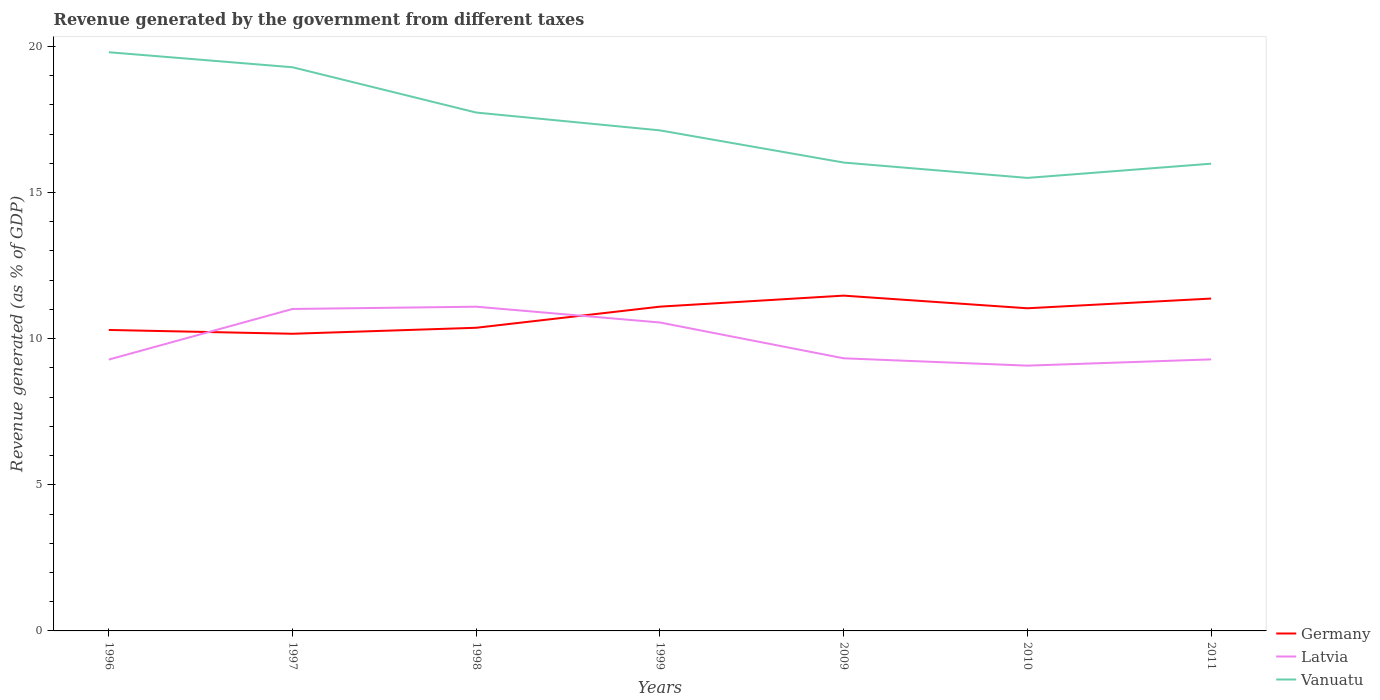Does the line corresponding to Germany intersect with the line corresponding to Latvia?
Your answer should be compact. Yes. Across all years, what is the maximum revenue generated by the government in Vanuatu?
Your response must be concise. 15.5. What is the total revenue generated by the government in Vanuatu in the graph?
Give a very brief answer. 2.24. What is the difference between the highest and the second highest revenue generated by the government in Germany?
Offer a terse response. 1.3. What is the difference between the highest and the lowest revenue generated by the government in Vanuatu?
Give a very brief answer. 3. Is the revenue generated by the government in Latvia strictly greater than the revenue generated by the government in Germany over the years?
Offer a terse response. No. How many lines are there?
Your answer should be very brief. 3. How many years are there in the graph?
Give a very brief answer. 7. Are the values on the major ticks of Y-axis written in scientific E-notation?
Give a very brief answer. No. Does the graph contain any zero values?
Offer a terse response. No. Where does the legend appear in the graph?
Provide a succinct answer. Bottom right. What is the title of the graph?
Keep it short and to the point. Revenue generated by the government from different taxes. What is the label or title of the Y-axis?
Give a very brief answer. Revenue generated (as % of GDP). What is the Revenue generated (as % of GDP) in Germany in 1996?
Offer a very short reply. 10.3. What is the Revenue generated (as % of GDP) in Latvia in 1996?
Your answer should be compact. 9.28. What is the Revenue generated (as % of GDP) in Vanuatu in 1996?
Provide a succinct answer. 19.8. What is the Revenue generated (as % of GDP) of Germany in 1997?
Your answer should be compact. 10.17. What is the Revenue generated (as % of GDP) of Latvia in 1997?
Ensure brevity in your answer.  11.02. What is the Revenue generated (as % of GDP) of Vanuatu in 1997?
Offer a terse response. 19.28. What is the Revenue generated (as % of GDP) of Germany in 1998?
Give a very brief answer. 10.37. What is the Revenue generated (as % of GDP) in Latvia in 1998?
Offer a very short reply. 11.09. What is the Revenue generated (as % of GDP) in Vanuatu in 1998?
Your answer should be compact. 17.73. What is the Revenue generated (as % of GDP) of Germany in 1999?
Your answer should be compact. 11.09. What is the Revenue generated (as % of GDP) of Latvia in 1999?
Keep it short and to the point. 10.55. What is the Revenue generated (as % of GDP) in Vanuatu in 1999?
Ensure brevity in your answer.  17.13. What is the Revenue generated (as % of GDP) in Germany in 2009?
Your answer should be compact. 11.47. What is the Revenue generated (as % of GDP) in Latvia in 2009?
Your answer should be compact. 9.33. What is the Revenue generated (as % of GDP) in Vanuatu in 2009?
Provide a short and direct response. 16.02. What is the Revenue generated (as % of GDP) of Germany in 2010?
Ensure brevity in your answer.  11.04. What is the Revenue generated (as % of GDP) in Latvia in 2010?
Offer a terse response. 9.08. What is the Revenue generated (as % of GDP) of Vanuatu in 2010?
Make the answer very short. 15.5. What is the Revenue generated (as % of GDP) of Germany in 2011?
Your response must be concise. 11.37. What is the Revenue generated (as % of GDP) of Latvia in 2011?
Offer a very short reply. 9.29. What is the Revenue generated (as % of GDP) in Vanuatu in 2011?
Offer a terse response. 15.99. Across all years, what is the maximum Revenue generated (as % of GDP) of Germany?
Offer a terse response. 11.47. Across all years, what is the maximum Revenue generated (as % of GDP) in Latvia?
Your answer should be very brief. 11.09. Across all years, what is the maximum Revenue generated (as % of GDP) in Vanuatu?
Offer a very short reply. 19.8. Across all years, what is the minimum Revenue generated (as % of GDP) in Germany?
Ensure brevity in your answer.  10.17. Across all years, what is the minimum Revenue generated (as % of GDP) of Latvia?
Offer a very short reply. 9.08. Across all years, what is the minimum Revenue generated (as % of GDP) of Vanuatu?
Offer a very short reply. 15.5. What is the total Revenue generated (as % of GDP) of Germany in the graph?
Provide a succinct answer. 75.81. What is the total Revenue generated (as % of GDP) of Latvia in the graph?
Ensure brevity in your answer.  69.64. What is the total Revenue generated (as % of GDP) of Vanuatu in the graph?
Make the answer very short. 121.45. What is the difference between the Revenue generated (as % of GDP) in Germany in 1996 and that in 1997?
Your response must be concise. 0.13. What is the difference between the Revenue generated (as % of GDP) of Latvia in 1996 and that in 1997?
Give a very brief answer. -1.73. What is the difference between the Revenue generated (as % of GDP) in Vanuatu in 1996 and that in 1997?
Your answer should be compact. 0.51. What is the difference between the Revenue generated (as % of GDP) of Germany in 1996 and that in 1998?
Your answer should be very brief. -0.07. What is the difference between the Revenue generated (as % of GDP) in Latvia in 1996 and that in 1998?
Provide a short and direct response. -1.81. What is the difference between the Revenue generated (as % of GDP) in Vanuatu in 1996 and that in 1998?
Provide a short and direct response. 2.06. What is the difference between the Revenue generated (as % of GDP) in Germany in 1996 and that in 1999?
Your answer should be very brief. -0.8. What is the difference between the Revenue generated (as % of GDP) of Latvia in 1996 and that in 1999?
Give a very brief answer. -1.27. What is the difference between the Revenue generated (as % of GDP) of Vanuatu in 1996 and that in 1999?
Provide a succinct answer. 2.67. What is the difference between the Revenue generated (as % of GDP) of Germany in 1996 and that in 2009?
Your answer should be compact. -1.17. What is the difference between the Revenue generated (as % of GDP) in Latvia in 1996 and that in 2009?
Offer a terse response. -0.04. What is the difference between the Revenue generated (as % of GDP) of Vanuatu in 1996 and that in 2009?
Provide a succinct answer. 3.77. What is the difference between the Revenue generated (as % of GDP) of Germany in 1996 and that in 2010?
Keep it short and to the point. -0.74. What is the difference between the Revenue generated (as % of GDP) of Latvia in 1996 and that in 2010?
Keep it short and to the point. 0.21. What is the difference between the Revenue generated (as % of GDP) of Vanuatu in 1996 and that in 2010?
Provide a short and direct response. 4.3. What is the difference between the Revenue generated (as % of GDP) in Germany in 1996 and that in 2011?
Your answer should be compact. -1.07. What is the difference between the Revenue generated (as % of GDP) in Latvia in 1996 and that in 2011?
Keep it short and to the point. -0.01. What is the difference between the Revenue generated (as % of GDP) of Vanuatu in 1996 and that in 2011?
Give a very brief answer. 3.81. What is the difference between the Revenue generated (as % of GDP) of Germany in 1997 and that in 1998?
Offer a terse response. -0.21. What is the difference between the Revenue generated (as % of GDP) of Latvia in 1997 and that in 1998?
Your answer should be very brief. -0.08. What is the difference between the Revenue generated (as % of GDP) of Vanuatu in 1997 and that in 1998?
Your answer should be very brief. 1.55. What is the difference between the Revenue generated (as % of GDP) of Germany in 1997 and that in 1999?
Give a very brief answer. -0.93. What is the difference between the Revenue generated (as % of GDP) in Latvia in 1997 and that in 1999?
Give a very brief answer. 0.46. What is the difference between the Revenue generated (as % of GDP) in Vanuatu in 1997 and that in 1999?
Offer a terse response. 2.16. What is the difference between the Revenue generated (as % of GDP) of Germany in 1997 and that in 2009?
Provide a succinct answer. -1.3. What is the difference between the Revenue generated (as % of GDP) in Latvia in 1997 and that in 2009?
Give a very brief answer. 1.69. What is the difference between the Revenue generated (as % of GDP) in Vanuatu in 1997 and that in 2009?
Keep it short and to the point. 3.26. What is the difference between the Revenue generated (as % of GDP) of Germany in 1997 and that in 2010?
Provide a short and direct response. -0.87. What is the difference between the Revenue generated (as % of GDP) in Latvia in 1997 and that in 2010?
Give a very brief answer. 1.94. What is the difference between the Revenue generated (as % of GDP) in Vanuatu in 1997 and that in 2010?
Provide a short and direct response. 3.79. What is the difference between the Revenue generated (as % of GDP) in Germany in 1997 and that in 2011?
Provide a succinct answer. -1.2. What is the difference between the Revenue generated (as % of GDP) in Latvia in 1997 and that in 2011?
Keep it short and to the point. 1.72. What is the difference between the Revenue generated (as % of GDP) in Vanuatu in 1997 and that in 2011?
Keep it short and to the point. 3.3. What is the difference between the Revenue generated (as % of GDP) of Germany in 1998 and that in 1999?
Give a very brief answer. -0.72. What is the difference between the Revenue generated (as % of GDP) of Latvia in 1998 and that in 1999?
Offer a very short reply. 0.54. What is the difference between the Revenue generated (as % of GDP) of Vanuatu in 1998 and that in 1999?
Your response must be concise. 0.61. What is the difference between the Revenue generated (as % of GDP) in Germany in 1998 and that in 2009?
Make the answer very short. -1.1. What is the difference between the Revenue generated (as % of GDP) of Latvia in 1998 and that in 2009?
Provide a short and direct response. 1.77. What is the difference between the Revenue generated (as % of GDP) of Vanuatu in 1998 and that in 2009?
Offer a terse response. 1.71. What is the difference between the Revenue generated (as % of GDP) in Germany in 1998 and that in 2010?
Keep it short and to the point. -0.67. What is the difference between the Revenue generated (as % of GDP) of Latvia in 1998 and that in 2010?
Provide a succinct answer. 2.02. What is the difference between the Revenue generated (as % of GDP) of Vanuatu in 1998 and that in 2010?
Keep it short and to the point. 2.24. What is the difference between the Revenue generated (as % of GDP) of Germany in 1998 and that in 2011?
Offer a terse response. -1. What is the difference between the Revenue generated (as % of GDP) in Latvia in 1998 and that in 2011?
Your response must be concise. 1.8. What is the difference between the Revenue generated (as % of GDP) in Vanuatu in 1998 and that in 2011?
Give a very brief answer. 1.75. What is the difference between the Revenue generated (as % of GDP) in Germany in 1999 and that in 2009?
Offer a terse response. -0.38. What is the difference between the Revenue generated (as % of GDP) of Latvia in 1999 and that in 2009?
Ensure brevity in your answer.  1.23. What is the difference between the Revenue generated (as % of GDP) in Vanuatu in 1999 and that in 2009?
Your response must be concise. 1.1. What is the difference between the Revenue generated (as % of GDP) of Germany in 1999 and that in 2010?
Provide a short and direct response. 0.06. What is the difference between the Revenue generated (as % of GDP) of Latvia in 1999 and that in 2010?
Ensure brevity in your answer.  1.48. What is the difference between the Revenue generated (as % of GDP) of Vanuatu in 1999 and that in 2010?
Offer a very short reply. 1.63. What is the difference between the Revenue generated (as % of GDP) in Germany in 1999 and that in 2011?
Offer a terse response. -0.28. What is the difference between the Revenue generated (as % of GDP) of Latvia in 1999 and that in 2011?
Ensure brevity in your answer.  1.26. What is the difference between the Revenue generated (as % of GDP) in Vanuatu in 1999 and that in 2011?
Your response must be concise. 1.14. What is the difference between the Revenue generated (as % of GDP) of Germany in 2009 and that in 2010?
Keep it short and to the point. 0.43. What is the difference between the Revenue generated (as % of GDP) in Latvia in 2009 and that in 2010?
Provide a succinct answer. 0.25. What is the difference between the Revenue generated (as % of GDP) of Vanuatu in 2009 and that in 2010?
Your answer should be compact. 0.53. What is the difference between the Revenue generated (as % of GDP) of Germany in 2009 and that in 2011?
Provide a succinct answer. 0.1. What is the difference between the Revenue generated (as % of GDP) of Latvia in 2009 and that in 2011?
Provide a succinct answer. 0.04. What is the difference between the Revenue generated (as % of GDP) in Vanuatu in 2009 and that in 2011?
Your answer should be very brief. 0.04. What is the difference between the Revenue generated (as % of GDP) of Germany in 2010 and that in 2011?
Provide a short and direct response. -0.33. What is the difference between the Revenue generated (as % of GDP) in Latvia in 2010 and that in 2011?
Your answer should be very brief. -0.21. What is the difference between the Revenue generated (as % of GDP) of Vanuatu in 2010 and that in 2011?
Make the answer very short. -0.49. What is the difference between the Revenue generated (as % of GDP) in Germany in 1996 and the Revenue generated (as % of GDP) in Latvia in 1997?
Offer a terse response. -0.72. What is the difference between the Revenue generated (as % of GDP) of Germany in 1996 and the Revenue generated (as % of GDP) of Vanuatu in 1997?
Keep it short and to the point. -8.99. What is the difference between the Revenue generated (as % of GDP) of Latvia in 1996 and the Revenue generated (as % of GDP) of Vanuatu in 1997?
Keep it short and to the point. -10. What is the difference between the Revenue generated (as % of GDP) in Germany in 1996 and the Revenue generated (as % of GDP) in Latvia in 1998?
Provide a short and direct response. -0.8. What is the difference between the Revenue generated (as % of GDP) in Germany in 1996 and the Revenue generated (as % of GDP) in Vanuatu in 1998?
Provide a short and direct response. -7.44. What is the difference between the Revenue generated (as % of GDP) of Latvia in 1996 and the Revenue generated (as % of GDP) of Vanuatu in 1998?
Your answer should be very brief. -8.45. What is the difference between the Revenue generated (as % of GDP) in Germany in 1996 and the Revenue generated (as % of GDP) in Latvia in 1999?
Provide a succinct answer. -0.26. What is the difference between the Revenue generated (as % of GDP) of Germany in 1996 and the Revenue generated (as % of GDP) of Vanuatu in 1999?
Provide a succinct answer. -6.83. What is the difference between the Revenue generated (as % of GDP) in Latvia in 1996 and the Revenue generated (as % of GDP) in Vanuatu in 1999?
Offer a terse response. -7.84. What is the difference between the Revenue generated (as % of GDP) in Germany in 1996 and the Revenue generated (as % of GDP) in Latvia in 2009?
Offer a very short reply. 0.97. What is the difference between the Revenue generated (as % of GDP) of Germany in 1996 and the Revenue generated (as % of GDP) of Vanuatu in 2009?
Your response must be concise. -5.73. What is the difference between the Revenue generated (as % of GDP) of Latvia in 1996 and the Revenue generated (as % of GDP) of Vanuatu in 2009?
Ensure brevity in your answer.  -6.74. What is the difference between the Revenue generated (as % of GDP) of Germany in 1996 and the Revenue generated (as % of GDP) of Latvia in 2010?
Make the answer very short. 1.22. What is the difference between the Revenue generated (as % of GDP) in Germany in 1996 and the Revenue generated (as % of GDP) in Vanuatu in 2010?
Your response must be concise. -5.2. What is the difference between the Revenue generated (as % of GDP) of Latvia in 1996 and the Revenue generated (as % of GDP) of Vanuatu in 2010?
Keep it short and to the point. -6.21. What is the difference between the Revenue generated (as % of GDP) in Germany in 1996 and the Revenue generated (as % of GDP) in Vanuatu in 2011?
Your answer should be compact. -5.69. What is the difference between the Revenue generated (as % of GDP) in Latvia in 1996 and the Revenue generated (as % of GDP) in Vanuatu in 2011?
Offer a very short reply. -6.7. What is the difference between the Revenue generated (as % of GDP) in Germany in 1997 and the Revenue generated (as % of GDP) in Latvia in 1998?
Your response must be concise. -0.93. What is the difference between the Revenue generated (as % of GDP) in Germany in 1997 and the Revenue generated (as % of GDP) in Vanuatu in 1998?
Offer a terse response. -7.57. What is the difference between the Revenue generated (as % of GDP) in Latvia in 1997 and the Revenue generated (as % of GDP) in Vanuatu in 1998?
Your response must be concise. -6.72. What is the difference between the Revenue generated (as % of GDP) in Germany in 1997 and the Revenue generated (as % of GDP) in Latvia in 1999?
Keep it short and to the point. -0.39. What is the difference between the Revenue generated (as % of GDP) of Germany in 1997 and the Revenue generated (as % of GDP) of Vanuatu in 1999?
Provide a short and direct response. -6.96. What is the difference between the Revenue generated (as % of GDP) of Latvia in 1997 and the Revenue generated (as % of GDP) of Vanuatu in 1999?
Your response must be concise. -6.11. What is the difference between the Revenue generated (as % of GDP) of Germany in 1997 and the Revenue generated (as % of GDP) of Latvia in 2009?
Provide a short and direct response. 0.84. What is the difference between the Revenue generated (as % of GDP) in Germany in 1997 and the Revenue generated (as % of GDP) in Vanuatu in 2009?
Provide a short and direct response. -5.86. What is the difference between the Revenue generated (as % of GDP) of Latvia in 1997 and the Revenue generated (as % of GDP) of Vanuatu in 2009?
Your response must be concise. -5.01. What is the difference between the Revenue generated (as % of GDP) in Germany in 1997 and the Revenue generated (as % of GDP) in Latvia in 2010?
Keep it short and to the point. 1.09. What is the difference between the Revenue generated (as % of GDP) in Germany in 1997 and the Revenue generated (as % of GDP) in Vanuatu in 2010?
Provide a short and direct response. -5.33. What is the difference between the Revenue generated (as % of GDP) of Latvia in 1997 and the Revenue generated (as % of GDP) of Vanuatu in 2010?
Offer a terse response. -4.48. What is the difference between the Revenue generated (as % of GDP) in Germany in 1997 and the Revenue generated (as % of GDP) in Latvia in 2011?
Offer a very short reply. 0.88. What is the difference between the Revenue generated (as % of GDP) in Germany in 1997 and the Revenue generated (as % of GDP) in Vanuatu in 2011?
Give a very brief answer. -5.82. What is the difference between the Revenue generated (as % of GDP) in Latvia in 1997 and the Revenue generated (as % of GDP) in Vanuatu in 2011?
Ensure brevity in your answer.  -4.97. What is the difference between the Revenue generated (as % of GDP) in Germany in 1998 and the Revenue generated (as % of GDP) in Latvia in 1999?
Provide a short and direct response. -0.18. What is the difference between the Revenue generated (as % of GDP) of Germany in 1998 and the Revenue generated (as % of GDP) of Vanuatu in 1999?
Offer a terse response. -6.75. What is the difference between the Revenue generated (as % of GDP) in Latvia in 1998 and the Revenue generated (as % of GDP) in Vanuatu in 1999?
Give a very brief answer. -6.03. What is the difference between the Revenue generated (as % of GDP) in Germany in 1998 and the Revenue generated (as % of GDP) in Latvia in 2009?
Provide a succinct answer. 1.04. What is the difference between the Revenue generated (as % of GDP) in Germany in 1998 and the Revenue generated (as % of GDP) in Vanuatu in 2009?
Your response must be concise. -5.65. What is the difference between the Revenue generated (as % of GDP) in Latvia in 1998 and the Revenue generated (as % of GDP) in Vanuatu in 2009?
Your answer should be very brief. -4.93. What is the difference between the Revenue generated (as % of GDP) of Germany in 1998 and the Revenue generated (as % of GDP) of Latvia in 2010?
Offer a terse response. 1.3. What is the difference between the Revenue generated (as % of GDP) in Germany in 1998 and the Revenue generated (as % of GDP) in Vanuatu in 2010?
Ensure brevity in your answer.  -5.13. What is the difference between the Revenue generated (as % of GDP) of Latvia in 1998 and the Revenue generated (as % of GDP) of Vanuatu in 2010?
Keep it short and to the point. -4.41. What is the difference between the Revenue generated (as % of GDP) of Germany in 1998 and the Revenue generated (as % of GDP) of Latvia in 2011?
Provide a succinct answer. 1.08. What is the difference between the Revenue generated (as % of GDP) in Germany in 1998 and the Revenue generated (as % of GDP) in Vanuatu in 2011?
Offer a very short reply. -5.61. What is the difference between the Revenue generated (as % of GDP) in Latvia in 1998 and the Revenue generated (as % of GDP) in Vanuatu in 2011?
Offer a terse response. -4.89. What is the difference between the Revenue generated (as % of GDP) of Germany in 1999 and the Revenue generated (as % of GDP) of Latvia in 2009?
Offer a very short reply. 1.77. What is the difference between the Revenue generated (as % of GDP) of Germany in 1999 and the Revenue generated (as % of GDP) of Vanuatu in 2009?
Keep it short and to the point. -4.93. What is the difference between the Revenue generated (as % of GDP) of Latvia in 1999 and the Revenue generated (as % of GDP) of Vanuatu in 2009?
Keep it short and to the point. -5.47. What is the difference between the Revenue generated (as % of GDP) of Germany in 1999 and the Revenue generated (as % of GDP) of Latvia in 2010?
Offer a terse response. 2.02. What is the difference between the Revenue generated (as % of GDP) of Germany in 1999 and the Revenue generated (as % of GDP) of Vanuatu in 2010?
Give a very brief answer. -4.4. What is the difference between the Revenue generated (as % of GDP) of Latvia in 1999 and the Revenue generated (as % of GDP) of Vanuatu in 2010?
Your answer should be very brief. -4.95. What is the difference between the Revenue generated (as % of GDP) of Germany in 1999 and the Revenue generated (as % of GDP) of Latvia in 2011?
Provide a short and direct response. 1.8. What is the difference between the Revenue generated (as % of GDP) in Germany in 1999 and the Revenue generated (as % of GDP) in Vanuatu in 2011?
Give a very brief answer. -4.89. What is the difference between the Revenue generated (as % of GDP) of Latvia in 1999 and the Revenue generated (as % of GDP) of Vanuatu in 2011?
Your response must be concise. -5.43. What is the difference between the Revenue generated (as % of GDP) in Germany in 2009 and the Revenue generated (as % of GDP) in Latvia in 2010?
Your answer should be very brief. 2.4. What is the difference between the Revenue generated (as % of GDP) in Germany in 2009 and the Revenue generated (as % of GDP) in Vanuatu in 2010?
Offer a terse response. -4.03. What is the difference between the Revenue generated (as % of GDP) of Latvia in 2009 and the Revenue generated (as % of GDP) of Vanuatu in 2010?
Make the answer very short. -6.17. What is the difference between the Revenue generated (as % of GDP) of Germany in 2009 and the Revenue generated (as % of GDP) of Latvia in 2011?
Provide a short and direct response. 2.18. What is the difference between the Revenue generated (as % of GDP) in Germany in 2009 and the Revenue generated (as % of GDP) in Vanuatu in 2011?
Your answer should be compact. -4.51. What is the difference between the Revenue generated (as % of GDP) in Latvia in 2009 and the Revenue generated (as % of GDP) in Vanuatu in 2011?
Keep it short and to the point. -6.66. What is the difference between the Revenue generated (as % of GDP) in Germany in 2010 and the Revenue generated (as % of GDP) in Latvia in 2011?
Give a very brief answer. 1.75. What is the difference between the Revenue generated (as % of GDP) of Germany in 2010 and the Revenue generated (as % of GDP) of Vanuatu in 2011?
Ensure brevity in your answer.  -4.95. What is the difference between the Revenue generated (as % of GDP) of Latvia in 2010 and the Revenue generated (as % of GDP) of Vanuatu in 2011?
Provide a succinct answer. -6.91. What is the average Revenue generated (as % of GDP) in Germany per year?
Make the answer very short. 10.83. What is the average Revenue generated (as % of GDP) in Latvia per year?
Keep it short and to the point. 9.95. What is the average Revenue generated (as % of GDP) in Vanuatu per year?
Ensure brevity in your answer.  17.35. In the year 1996, what is the difference between the Revenue generated (as % of GDP) of Germany and Revenue generated (as % of GDP) of Latvia?
Your answer should be very brief. 1.01. In the year 1996, what is the difference between the Revenue generated (as % of GDP) of Germany and Revenue generated (as % of GDP) of Vanuatu?
Ensure brevity in your answer.  -9.5. In the year 1996, what is the difference between the Revenue generated (as % of GDP) of Latvia and Revenue generated (as % of GDP) of Vanuatu?
Provide a short and direct response. -10.51. In the year 1997, what is the difference between the Revenue generated (as % of GDP) of Germany and Revenue generated (as % of GDP) of Latvia?
Keep it short and to the point. -0.85. In the year 1997, what is the difference between the Revenue generated (as % of GDP) of Germany and Revenue generated (as % of GDP) of Vanuatu?
Provide a short and direct response. -9.12. In the year 1997, what is the difference between the Revenue generated (as % of GDP) of Latvia and Revenue generated (as % of GDP) of Vanuatu?
Your response must be concise. -8.27. In the year 1998, what is the difference between the Revenue generated (as % of GDP) in Germany and Revenue generated (as % of GDP) in Latvia?
Keep it short and to the point. -0.72. In the year 1998, what is the difference between the Revenue generated (as % of GDP) in Germany and Revenue generated (as % of GDP) in Vanuatu?
Offer a terse response. -7.36. In the year 1998, what is the difference between the Revenue generated (as % of GDP) in Latvia and Revenue generated (as % of GDP) in Vanuatu?
Provide a short and direct response. -6.64. In the year 1999, what is the difference between the Revenue generated (as % of GDP) in Germany and Revenue generated (as % of GDP) in Latvia?
Offer a terse response. 0.54. In the year 1999, what is the difference between the Revenue generated (as % of GDP) of Germany and Revenue generated (as % of GDP) of Vanuatu?
Your answer should be very brief. -6.03. In the year 1999, what is the difference between the Revenue generated (as % of GDP) in Latvia and Revenue generated (as % of GDP) in Vanuatu?
Your response must be concise. -6.57. In the year 2009, what is the difference between the Revenue generated (as % of GDP) in Germany and Revenue generated (as % of GDP) in Latvia?
Provide a short and direct response. 2.14. In the year 2009, what is the difference between the Revenue generated (as % of GDP) in Germany and Revenue generated (as % of GDP) in Vanuatu?
Make the answer very short. -4.55. In the year 2009, what is the difference between the Revenue generated (as % of GDP) in Latvia and Revenue generated (as % of GDP) in Vanuatu?
Offer a terse response. -6.7. In the year 2010, what is the difference between the Revenue generated (as % of GDP) in Germany and Revenue generated (as % of GDP) in Latvia?
Make the answer very short. 1.96. In the year 2010, what is the difference between the Revenue generated (as % of GDP) in Germany and Revenue generated (as % of GDP) in Vanuatu?
Provide a succinct answer. -4.46. In the year 2010, what is the difference between the Revenue generated (as % of GDP) in Latvia and Revenue generated (as % of GDP) in Vanuatu?
Offer a very short reply. -6.42. In the year 2011, what is the difference between the Revenue generated (as % of GDP) of Germany and Revenue generated (as % of GDP) of Latvia?
Your response must be concise. 2.08. In the year 2011, what is the difference between the Revenue generated (as % of GDP) of Germany and Revenue generated (as % of GDP) of Vanuatu?
Make the answer very short. -4.61. In the year 2011, what is the difference between the Revenue generated (as % of GDP) in Latvia and Revenue generated (as % of GDP) in Vanuatu?
Keep it short and to the point. -6.7. What is the ratio of the Revenue generated (as % of GDP) in Germany in 1996 to that in 1997?
Provide a succinct answer. 1.01. What is the ratio of the Revenue generated (as % of GDP) of Latvia in 1996 to that in 1997?
Offer a very short reply. 0.84. What is the ratio of the Revenue generated (as % of GDP) in Vanuatu in 1996 to that in 1997?
Your response must be concise. 1.03. What is the ratio of the Revenue generated (as % of GDP) of Latvia in 1996 to that in 1998?
Provide a succinct answer. 0.84. What is the ratio of the Revenue generated (as % of GDP) of Vanuatu in 1996 to that in 1998?
Provide a short and direct response. 1.12. What is the ratio of the Revenue generated (as % of GDP) of Germany in 1996 to that in 1999?
Give a very brief answer. 0.93. What is the ratio of the Revenue generated (as % of GDP) of Latvia in 1996 to that in 1999?
Give a very brief answer. 0.88. What is the ratio of the Revenue generated (as % of GDP) in Vanuatu in 1996 to that in 1999?
Offer a terse response. 1.16. What is the ratio of the Revenue generated (as % of GDP) in Germany in 1996 to that in 2009?
Ensure brevity in your answer.  0.9. What is the ratio of the Revenue generated (as % of GDP) in Vanuatu in 1996 to that in 2009?
Your answer should be compact. 1.24. What is the ratio of the Revenue generated (as % of GDP) of Germany in 1996 to that in 2010?
Provide a short and direct response. 0.93. What is the ratio of the Revenue generated (as % of GDP) in Latvia in 1996 to that in 2010?
Provide a short and direct response. 1.02. What is the ratio of the Revenue generated (as % of GDP) of Vanuatu in 1996 to that in 2010?
Your answer should be very brief. 1.28. What is the ratio of the Revenue generated (as % of GDP) of Germany in 1996 to that in 2011?
Make the answer very short. 0.91. What is the ratio of the Revenue generated (as % of GDP) of Vanuatu in 1996 to that in 2011?
Keep it short and to the point. 1.24. What is the ratio of the Revenue generated (as % of GDP) in Germany in 1997 to that in 1998?
Provide a succinct answer. 0.98. What is the ratio of the Revenue generated (as % of GDP) of Vanuatu in 1997 to that in 1998?
Offer a very short reply. 1.09. What is the ratio of the Revenue generated (as % of GDP) in Germany in 1997 to that in 1999?
Offer a terse response. 0.92. What is the ratio of the Revenue generated (as % of GDP) in Latvia in 1997 to that in 1999?
Your answer should be very brief. 1.04. What is the ratio of the Revenue generated (as % of GDP) of Vanuatu in 1997 to that in 1999?
Your answer should be very brief. 1.13. What is the ratio of the Revenue generated (as % of GDP) in Germany in 1997 to that in 2009?
Ensure brevity in your answer.  0.89. What is the ratio of the Revenue generated (as % of GDP) in Latvia in 1997 to that in 2009?
Your answer should be very brief. 1.18. What is the ratio of the Revenue generated (as % of GDP) in Vanuatu in 1997 to that in 2009?
Provide a succinct answer. 1.2. What is the ratio of the Revenue generated (as % of GDP) of Germany in 1997 to that in 2010?
Provide a succinct answer. 0.92. What is the ratio of the Revenue generated (as % of GDP) in Latvia in 1997 to that in 2010?
Keep it short and to the point. 1.21. What is the ratio of the Revenue generated (as % of GDP) in Vanuatu in 1997 to that in 2010?
Ensure brevity in your answer.  1.24. What is the ratio of the Revenue generated (as % of GDP) in Germany in 1997 to that in 2011?
Provide a succinct answer. 0.89. What is the ratio of the Revenue generated (as % of GDP) of Latvia in 1997 to that in 2011?
Provide a short and direct response. 1.19. What is the ratio of the Revenue generated (as % of GDP) in Vanuatu in 1997 to that in 2011?
Your answer should be very brief. 1.21. What is the ratio of the Revenue generated (as % of GDP) of Germany in 1998 to that in 1999?
Your answer should be compact. 0.93. What is the ratio of the Revenue generated (as % of GDP) of Latvia in 1998 to that in 1999?
Ensure brevity in your answer.  1.05. What is the ratio of the Revenue generated (as % of GDP) in Vanuatu in 1998 to that in 1999?
Offer a terse response. 1.04. What is the ratio of the Revenue generated (as % of GDP) in Germany in 1998 to that in 2009?
Your answer should be compact. 0.9. What is the ratio of the Revenue generated (as % of GDP) of Latvia in 1998 to that in 2009?
Provide a succinct answer. 1.19. What is the ratio of the Revenue generated (as % of GDP) in Vanuatu in 1998 to that in 2009?
Give a very brief answer. 1.11. What is the ratio of the Revenue generated (as % of GDP) of Germany in 1998 to that in 2010?
Provide a succinct answer. 0.94. What is the ratio of the Revenue generated (as % of GDP) of Latvia in 1998 to that in 2010?
Your answer should be very brief. 1.22. What is the ratio of the Revenue generated (as % of GDP) of Vanuatu in 1998 to that in 2010?
Provide a short and direct response. 1.14. What is the ratio of the Revenue generated (as % of GDP) of Germany in 1998 to that in 2011?
Provide a succinct answer. 0.91. What is the ratio of the Revenue generated (as % of GDP) in Latvia in 1998 to that in 2011?
Your answer should be very brief. 1.19. What is the ratio of the Revenue generated (as % of GDP) of Vanuatu in 1998 to that in 2011?
Make the answer very short. 1.11. What is the ratio of the Revenue generated (as % of GDP) of Germany in 1999 to that in 2009?
Give a very brief answer. 0.97. What is the ratio of the Revenue generated (as % of GDP) of Latvia in 1999 to that in 2009?
Provide a short and direct response. 1.13. What is the ratio of the Revenue generated (as % of GDP) in Vanuatu in 1999 to that in 2009?
Provide a short and direct response. 1.07. What is the ratio of the Revenue generated (as % of GDP) of Latvia in 1999 to that in 2010?
Your answer should be compact. 1.16. What is the ratio of the Revenue generated (as % of GDP) in Vanuatu in 1999 to that in 2010?
Your answer should be compact. 1.1. What is the ratio of the Revenue generated (as % of GDP) in Germany in 1999 to that in 2011?
Give a very brief answer. 0.98. What is the ratio of the Revenue generated (as % of GDP) of Latvia in 1999 to that in 2011?
Make the answer very short. 1.14. What is the ratio of the Revenue generated (as % of GDP) of Vanuatu in 1999 to that in 2011?
Ensure brevity in your answer.  1.07. What is the ratio of the Revenue generated (as % of GDP) in Germany in 2009 to that in 2010?
Give a very brief answer. 1.04. What is the ratio of the Revenue generated (as % of GDP) in Latvia in 2009 to that in 2010?
Make the answer very short. 1.03. What is the ratio of the Revenue generated (as % of GDP) of Vanuatu in 2009 to that in 2010?
Your response must be concise. 1.03. What is the ratio of the Revenue generated (as % of GDP) in Germany in 2009 to that in 2011?
Provide a short and direct response. 1.01. What is the ratio of the Revenue generated (as % of GDP) of Latvia in 2009 to that in 2011?
Your answer should be compact. 1. What is the ratio of the Revenue generated (as % of GDP) of Vanuatu in 2009 to that in 2011?
Your response must be concise. 1. What is the ratio of the Revenue generated (as % of GDP) of Germany in 2010 to that in 2011?
Make the answer very short. 0.97. What is the ratio of the Revenue generated (as % of GDP) in Latvia in 2010 to that in 2011?
Give a very brief answer. 0.98. What is the ratio of the Revenue generated (as % of GDP) of Vanuatu in 2010 to that in 2011?
Your response must be concise. 0.97. What is the difference between the highest and the second highest Revenue generated (as % of GDP) of Germany?
Your response must be concise. 0.1. What is the difference between the highest and the second highest Revenue generated (as % of GDP) of Latvia?
Provide a succinct answer. 0.08. What is the difference between the highest and the second highest Revenue generated (as % of GDP) in Vanuatu?
Offer a terse response. 0.51. What is the difference between the highest and the lowest Revenue generated (as % of GDP) in Germany?
Offer a terse response. 1.3. What is the difference between the highest and the lowest Revenue generated (as % of GDP) of Latvia?
Your answer should be very brief. 2.02. What is the difference between the highest and the lowest Revenue generated (as % of GDP) in Vanuatu?
Your answer should be compact. 4.3. 